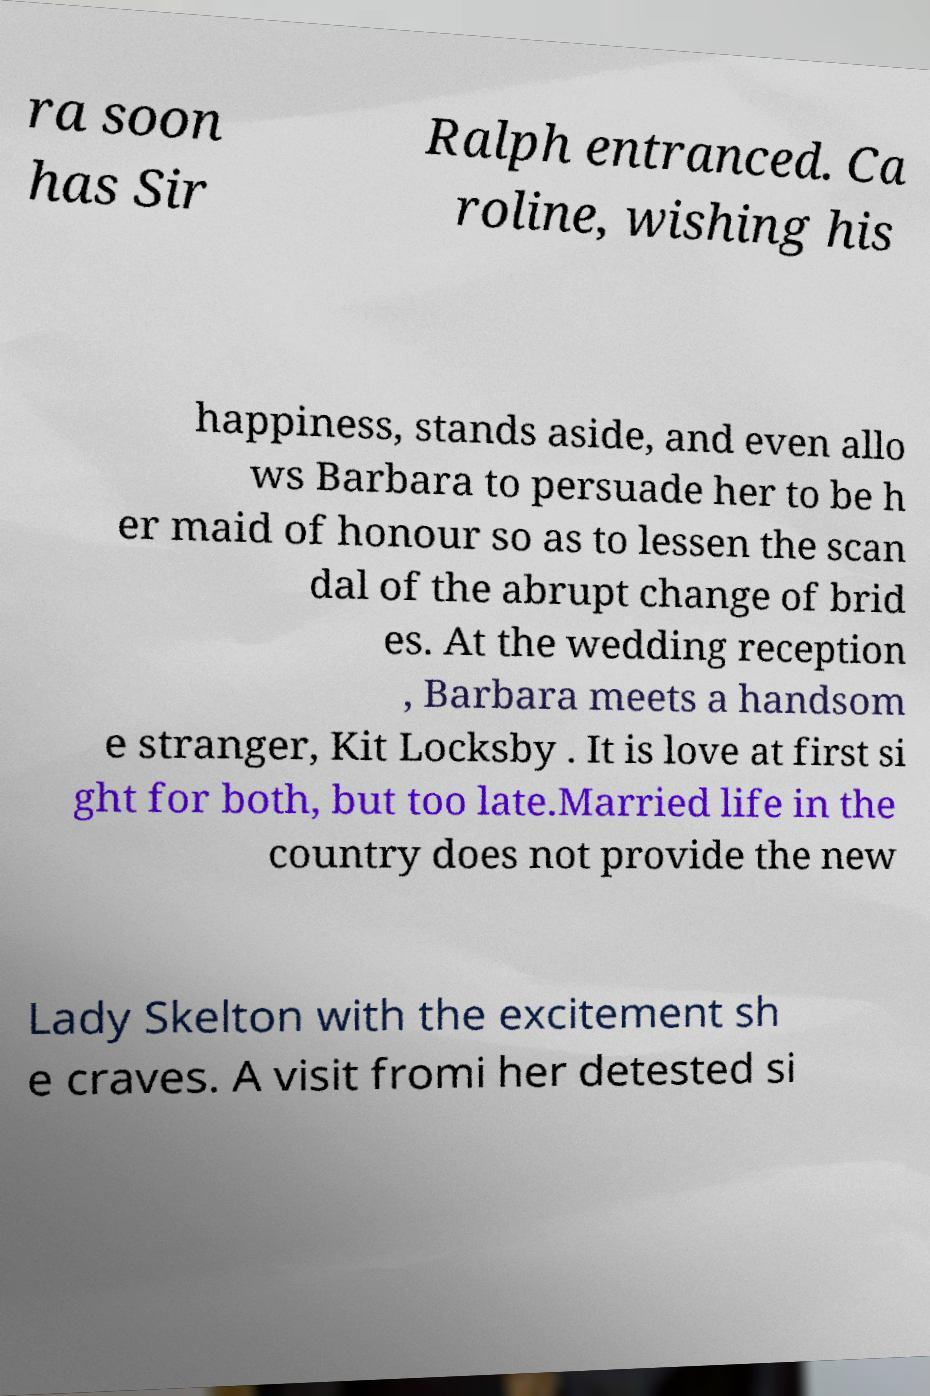For documentation purposes, I need the text within this image transcribed. Could you provide that? ra soon has Sir Ralph entranced. Ca roline, wishing his happiness, stands aside, and even allo ws Barbara to persuade her to be h er maid of honour so as to lessen the scan dal of the abrupt change of brid es. At the wedding reception , Barbara meets a handsom e stranger, Kit Locksby . It is love at first si ght for both, but too late.Married life in the country does not provide the new Lady Skelton with the excitement sh e craves. A visit fromi her detested si 